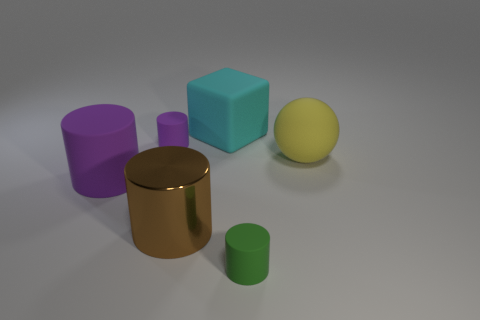The big sphere that is made of the same material as the small green thing is what color?
Ensure brevity in your answer.  Yellow. Is the material of the tiny purple thing the same as the small thing on the right side of the metal cylinder?
Ensure brevity in your answer.  Yes. The matte thing that is right of the big cyan thing and behind the green matte object is what color?
Your response must be concise. Yellow. What number of cylinders are either large green rubber things or matte objects?
Your answer should be very brief. 3. There is a tiny purple object; does it have the same shape as the tiny thing right of the big cyan block?
Your answer should be very brief. Yes. There is a object that is to the right of the big matte block and left of the big yellow sphere; what is its size?
Your response must be concise. Small. There is a tiny purple matte object; what shape is it?
Give a very brief answer. Cylinder. There is a tiny cylinder to the left of the green matte object; is there a big cyan rubber cube right of it?
Offer a terse response. Yes. How many large yellow matte spheres are right of the tiny object that is on the right side of the brown metallic cylinder?
Keep it short and to the point. 1. What material is the brown cylinder that is the same size as the matte sphere?
Provide a succinct answer. Metal. 